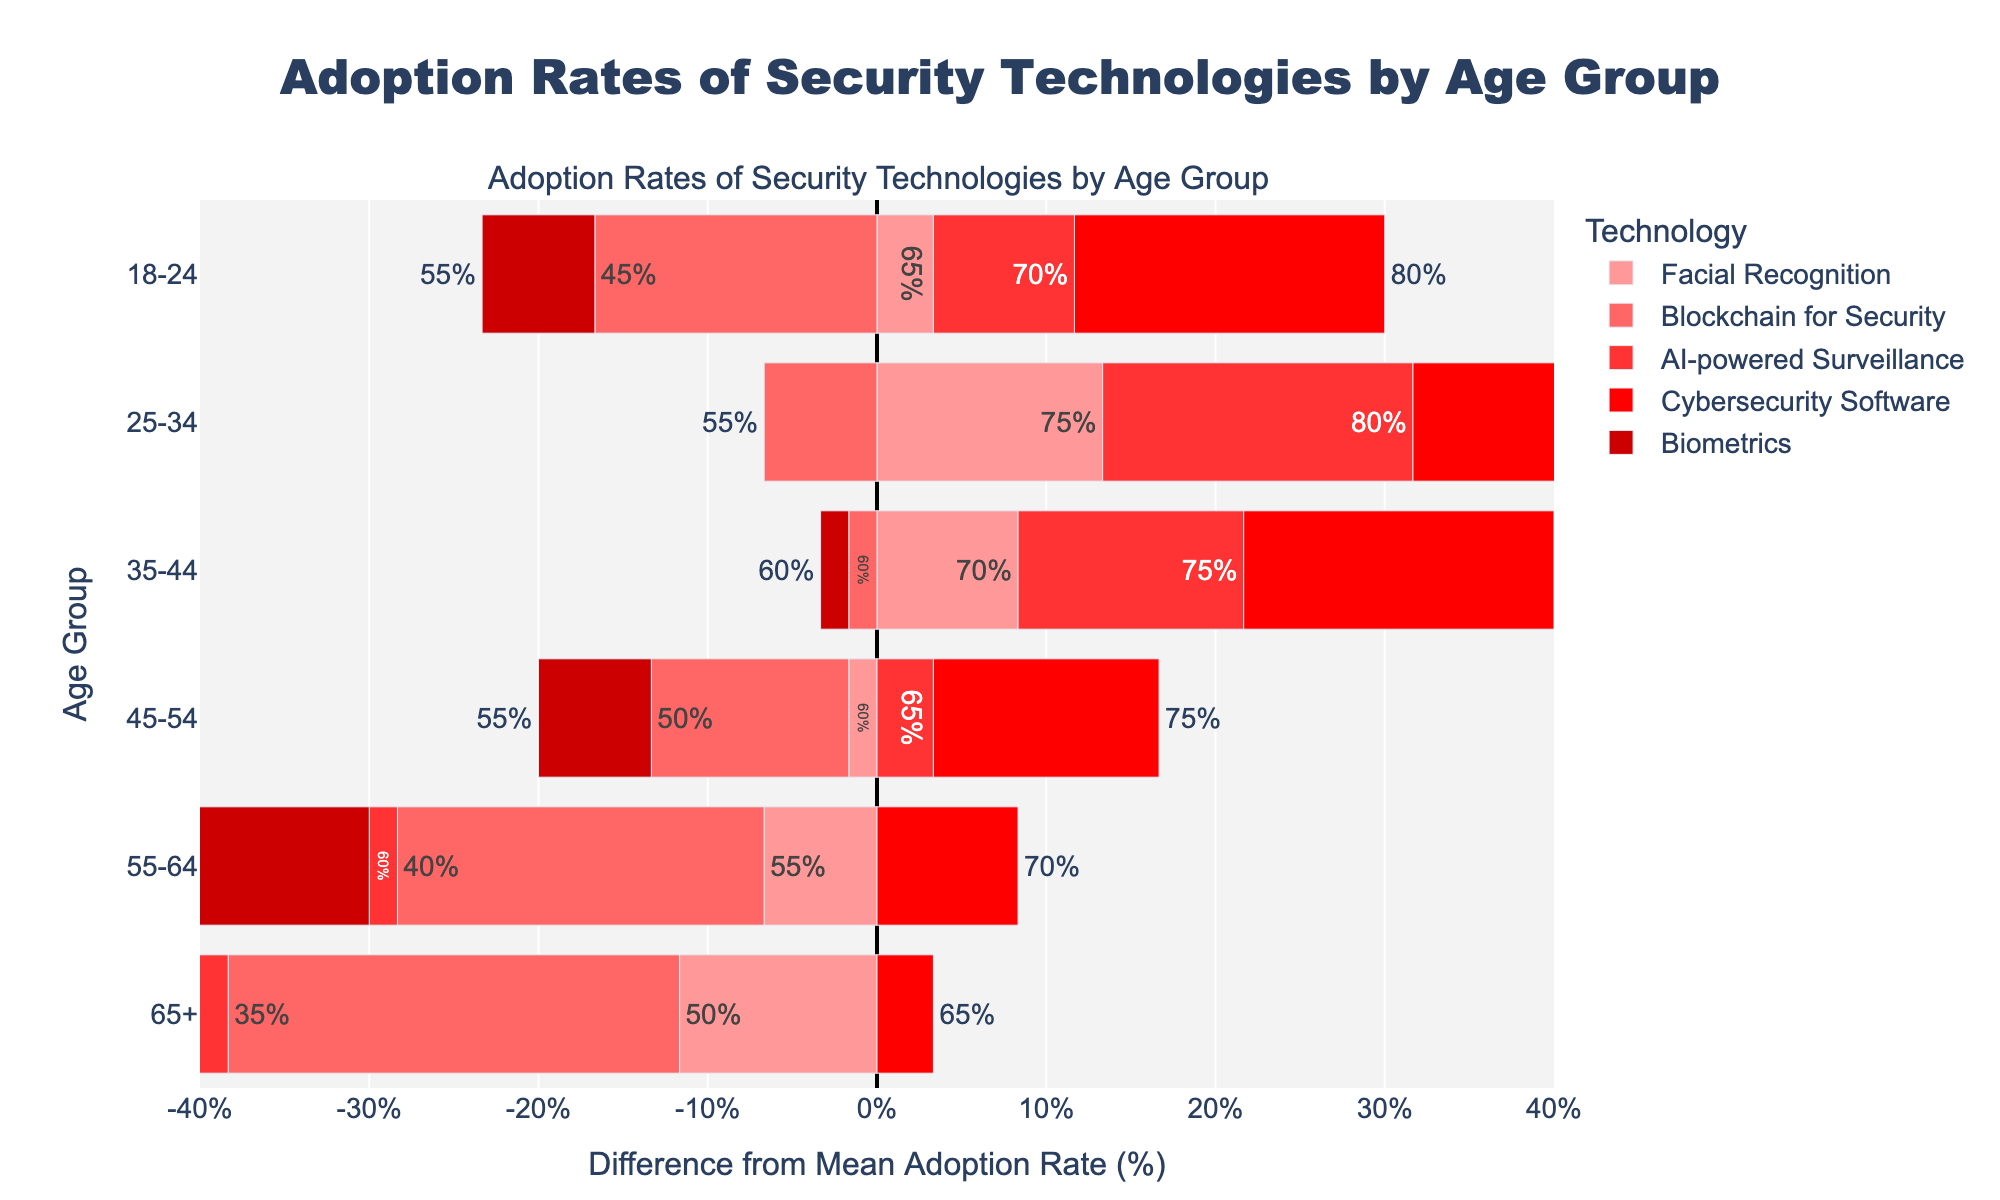Which age group shows the highest adoption rate for AI-powered Surveillance? To find the age group with the highest adoption rate for AI-powered Surveillance, look at the bars corresponding to 'AI-powered Surveillance' and identify the age group with the longest bar.
Answer: 25-34 How much higher is the adoption rate of Cybersecurity Software for the 25-34 age group compared to the 65+ age group? Compare the length of the bars for Cybersecurity Software in the 25-34 and 65+ age groups. The difference in adoption rates is 85% - 65% = 20%.
Answer: 20% Which technology has the lowest adoption rate among the 18-24 age group? To find the technology with the lowest adoption rate among the 18-24 age group, identify the shortest bar within the '18-24' category.
Answer: Blockchain for Security Over all age groups, which technology had the most consistent adoption rate? Compare the lengths of the bars for each technology across all age groups to determine which has the smallest variance in bar lengths. Cybersecurity Software bars appear more consistent in length across all age groups.
Answer: Cybersecurity Software How does the adoption rate of Biometrics for the 45-54 age group compare to the mean adoption rate? First, calculate how far the adoption rate for Biometrics (55%) deviates from the mean adoption rate. Determine if 55% is above, below, or equal to the mean.
Answer: Below_mean For the age group 55-64, which technology shows the most significant deviation from the mean adoption rate? For the age group 55-64, identify the technology with the bar that deviates most towards either end of the x-axis (positive or negative).
Answer: Blockchain for Security What is the range of adoption rates for Facial Recognition across all age groups? Identify the highest (75%) and lowest (50%) adoption rates for Facial Recognition by comparing the lengths of the corresponding bars. Calculate the range by subtracting the lowest rate from the highest rate.
Answer: 25% Does the adoption rate of AI-powered Surveillance generally increase or decrease with age? Observe the trend in bar lengths for AI-powered Surveillance from 18-24 to 65+. Note if the bars generally increase or decrease in length.
Answer: Decrease Which age group has the closest average adoption rate to the overall mean adoption rate? Calculate the average adoption rate for each age group by summing the adoption rates of all technologies and dividing by the number of technologies (5). Compare each group's average to the overall mean adoption rate to find the closest match. 65+, with an average adoption rate of 52%, is closest to the mean adoption rate of 61%.
Answer: 65+ How does the adoption rate of Blockchain for Security compare across the different age groups? Look at the bars for Blockchain for Security across all age groups and compare their lengths to describe the variations. The adoption rate decreases steadily from 18-24 (45%) to 65+ (35%).
Answer: It_decreases_with_age 